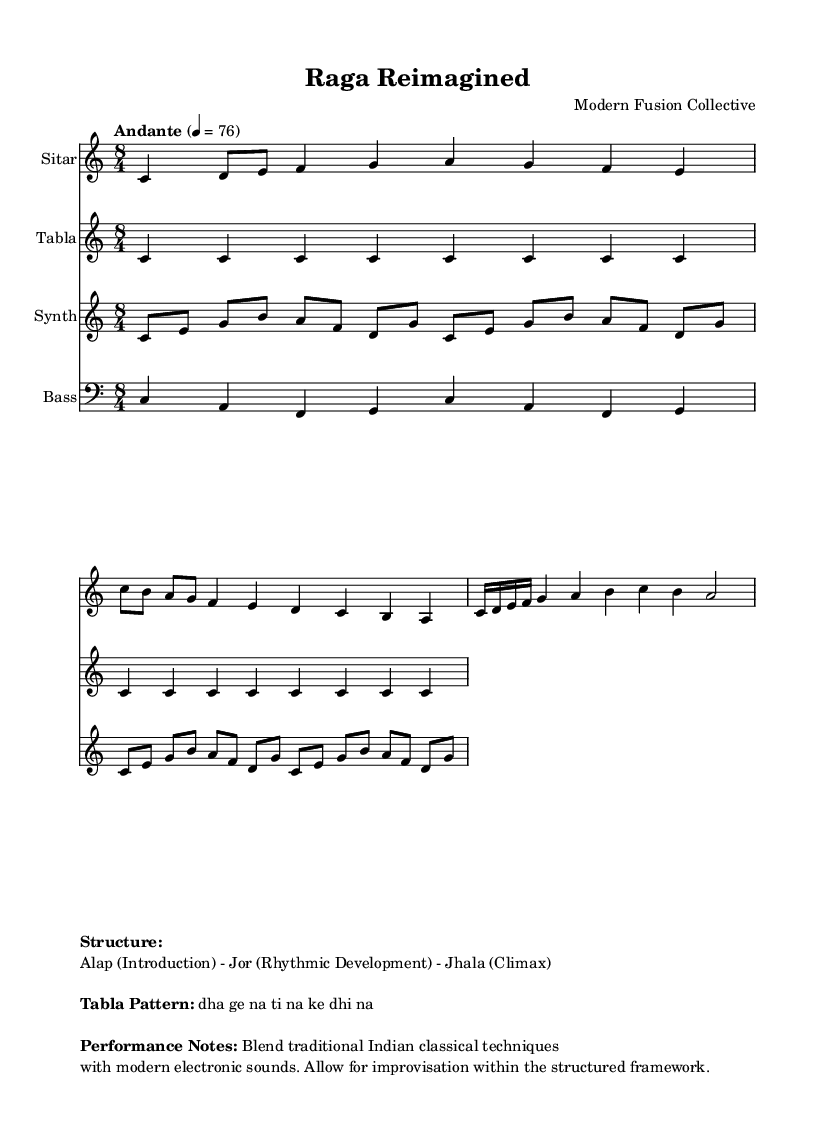What is the key signature of this music? The key signature is indicated as C major, which can be identified by the absence of any accidentals (sharps or flats).
Answer: C major What is the time signature? The time signature is represented as 8/4 at the beginning of the music, indicating that there are eight beats in a measure and a quarter note gets one beat.
Answer: 8/4 What is the tempo marking? The tempo marking is found in the score stating "Andante" with a metronome indication of 76, describing a moderate walking pace.
Answer: Andante 4 = 76 How many repetitions does the Tabla pattern occur? The score shows that the Tabla pattern repeats two times, indicated by the instruction \repeat unfold 2.
Answer: 2 Which section of the music corresponds to the climax? The climax is indicated as "Jhala", which is the final and most intense section of the piece that represents the peak of the performance.
Answer: Jhala What are the main instruments used in this composition? The main instruments can be identified from the score as the Sitar, Tabla, Synth, and Bass, each indicated by their respective staff.
Answer: Sitar, Tabla, Synth, Bass What is the rhythmic pattern for the Tabla? The rhythmic pattern is notated as "dha ge na ti na ke dhi na", representing the traditional strokes used in Indian classical music for Tabla.
Answer: dha ge na ti na ke dhi na 